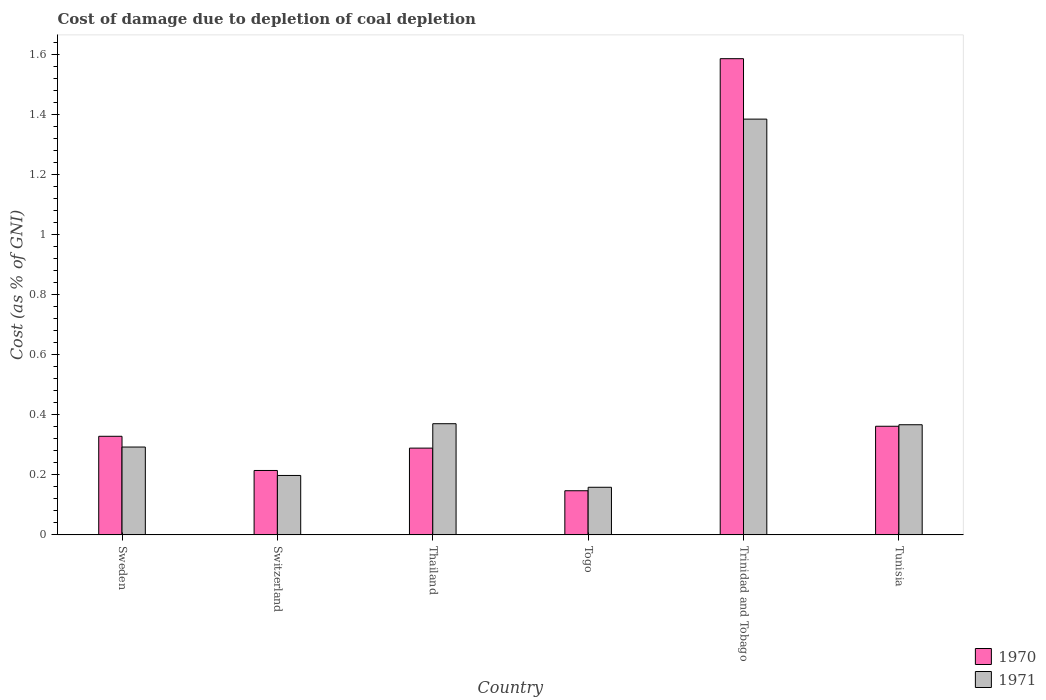How many groups of bars are there?
Offer a terse response. 6. Are the number of bars on each tick of the X-axis equal?
Keep it short and to the point. Yes. How many bars are there on the 6th tick from the left?
Provide a short and direct response. 2. What is the label of the 3rd group of bars from the left?
Your answer should be compact. Thailand. What is the cost of damage caused due to coal depletion in 1971 in Switzerland?
Offer a terse response. 0.2. Across all countries, what is the maximum cost of damage caused due to coal depletion in 1971?
Ensure brevity in your answer.  1.39. Across all countries, what is the minimum cost of damage caused due to coal depletion in 1971?
Provide a succinct answer. 0.16. In which country was the cost of damage caused due to coal depletion in 1970 maximum?
Provide a succinct answer. Trinidad and Tobago. In which country was the cost of damage caused due to coal depletion in 1970 minimum?
Your answer should be very brief. Togo. What is the total cost of damage caused due to coal depletion in 1970 in the graph?
Your answer should be very brief. 2.93. What is the difference between the cost of damage caused due to coal depletion in 1971 in Trinidad and Tobago and that in Tunisia?
Keep it short and to the point. 1.02. What is the difference between the cost of damage caused due to coal depletion in 1971 in Switzerland and the cost of damage caused due to coal depletion in 1970 in Trinidad and Tobago?
Your response must be concise. -1.39. What is the average cost of damage caused due to coal depletion in 1971 per country?
Offer a very short reply. 0.46. What is the difference between the cost of damage caused due to coal depletion of/in 1971 and cost of damage caused due to coal depletion of/in 1970 in Switzerland?
Provide a short and direct response. -0.02. What is the ratio of the cost of damage caused due to coal depletion in 1970 in Sweden to that in Tunisia?
Keep it short and to the point. 0.91. Is the cost of damage caused due to coal depletion in 1971 in Togo less than that in Trinidad and Tobago?
Your answer should be compact. Yes. What is the difference between the highest and the second highest cost of damage caused due to coal depletion in 1970?
Give a very brief answer. -1.23. What is the difference between the highest and the lowest cost of damage caused due to coal depletion in 1970?
Your answer should be very brief. 1.44. In how many countries, is the cost of damage caused due to coal depletion in 1971 greater than the average cost of damage caused due to coal depletion in 1971 taken over all countries?
Your answer should be compact. 1. How many bars are there?
Your answer should be compact. 12. Are all the bars in the graph horizontal?
Ensure brevity in your answer.  No. How many countries are there in the graph?
Your answer should be compact. 6. What is the difference between two consecutive major ticks on the Y-axis?
Offer a terse response. 0.2. Are the values on the major ticks of Y-axis written in scientific E-notation?
Offer a very short reply. No. Does the graph contain any zero values?
Offer a terse response. No. How are the legend labels stacked?
Offer a very short reply. Vertical. What is the title of the graph?
Ensure brevity in your answer.  Cost of damage due to depletion of coal depletion. Does "1987" appear as one of the legend labels in the graph?
Make the answer very short. No. What is the label or title of the X-axis?
Offer a very short reply. Country. What is the label or title of the Y-axis?
Offer a terse response. Cost (as % of GNI). What is the Cost (as % of GNI) in 1970 in Sweden?
Your response must be concise. 0.33. What is the Cost (as % of GNI) in 1971 in Sweden?
Provide a succinct answer. 0.29. What is the Cost (as % of GNI) in 1970 in Switzerland?
Provide a succinct answer. 0.21. What is the Cost (as % of GNI) in 1971 in Switzerland?
Give a very brief answer. 0.2. What is the Cost (as % of GNI) of 1970 in Thailand?
Provide a short and direct response. 0.29. What is the Cost (as % of GNI) of 1971 in Thailand?
Make the answer very short. 0.37. What is the Cost (as % of GNI) of 1970 in Togo?
Your answer should be very brief. 0.15. What is the Cost (as % of GNI) of 1971 in Togo?
Your response must be concise. 0.16. What is the Cost (as % of GNI) in 1970 in Trinidad and Tobago?
Offer a very short reply. 1.59. What is the Cost (as % of GNI) of 1971 in Trinidad and Tobago?
Keep it short and to the point. 1.39. What is the Cost (as % of GNI) in 1970 in Tunisia?
Your answer should be compact. 0.36. What is the Cost (as % of GNI) in 1971 in Tunisia?
Offer a terse response. 0.37. Across all countries, what is the maximum Cost (as % of GNI) in 1970?
Keep it short and to the point. 1.59. Across all countries, what is the maximum Cost (as % of GNI) in 1971?
Make the answer very short. 1.39. Across all countries, what is the minimum Cost (as % of GNI) of 1970?
Your response must be concise. 0.15. Across all countries, what is the minimum Cost (as % of GNI) of 1971?
Keep it short and to the point. 0.16. What is the total Cost (as % of GNI) of 1970 in the graph?
Your answer should be compact. 2.93. What is the total Cost (as % of GNI) in 1971 in the graph?
Offer a terse response. 2.77. What is the difference between the Cost (as % of GNI) of 1970 in Sweden and that in Switzerland?
Your answer should be compact. 0.11. What is the difference between the Cost (as % of GNI) of 1971 in Sweden and that in Switzerland?
Your answer should be compact. 0.09. What is the difference between the Cost (as % of GNI) of 1970 in Sweden and that in Thailand?
Offer a very short reply. 0.04. What is the difference between the Cost (as % of GNI) in 1971 in Sweden and that in Thailand?
Your answer should be very brief. -0.08. What is the difference between the Cost (as % of GNI) in 1970 in Sweden and that in Togo?
Offer a very short reply. 0.18. What is the difference between the Cost (as % of GNI) of 1971 in Sweden and that in Togo?
Provide a succinct answer. 0.13. What is the difference between the Cost (as % of GNI) in 1970 in Sweden and that in Trinidad and Tobago?
Ensure brevity in your answer.  -1.26. What is the difference between the Cost (as % of GNI) of 1971 in Sweden and that in Trinidad and Tobago?
Offer a terse response. -1.09. What is the difference between the Cost (as % of GNI) of 1970 in Sweden and that in Tunisia?
Your answer should be very brief. -0.03. What is the difference between the Cost (as % of GNI) in 1971 in Sweden and that in Tunisia?
Provide a succinct answer. -0.07. What is the difference between the Cost (as % of GNI) in 1970 in Switzerland and that in Thailand?
Provide a short and direct response. -0.07. What is the difference between the Cost (as % of GNI) in 1971 in Switzerland and that in Thailand?
Make the answer very short. -0.17. What is the difference between the Cost (as % of GNI) of 1970 in Switzerland and that in Togo?
Your response must be concise. 0.07. What is the difference between the Cost (as % of GNI) of 1971 in Switzerland and that in Togo?
Your answer should be very brief. 0.04. What is the difference between the Cost (as % of GNI) in 1970 in Switzerland and that in Trinidad and Tobago?
Provide a succinct answer. -1.37. What is the difference between the Cost (as % of GNI) in 1971 in Switzerland and that in Trinidad and Tobago?
Offer a terse response. -1.19. What is the difference between the Cost (as % of GNI) of 1970 in Switzerland and that in Tunisia?
Offer a terse response. -0.15. What is the difference between the Cost (as % of GNI) of 1971 in Switzerland and that in Tunisia?
Keep it short and to the point. -0.17. What is the difference between the Cost (as % of GNI) of 1970 in Thailand and that in Togo?
Your answer should be compact. 0.14. What is the difference between the Cost (as % of GNI) of 1971 in Thailand and that in Togo?
Your response must be concise. 0.21. What is the difference between the Cost (as % of GNI) of 1970 in Thailand and that in Trinidad and Tobago?
Offer a very short reply. -1.3. What is the difference between the Cost (as % of GNI) in 1971 in Thailand and that in Trinidad and Tobago?
Your answer should be very brief. -1.02. What is the difference between the Cost (as % of GNI) in 1970 in Thailand and that in Tunisia?
Make the answer very short. -0.07. What is the difference between the Cost (as % of GNI) in 1971 in Thailand and that in Tunisia?
Provide a succinct answer. 0. What is the difference between the Cost (as % of GNI) of 1970 in Togo and that in Trinidad and Tobago?
Make the answer very short. -1.44. What is the difference between the Cost (as % of GNI) in 1971 in Togo and that in Trinidad and Tobago?
Your answer should be very brief. -1.23. What is the difference between the Cost (as % of GNI) of 1970 in Togo and that in Tunisia?
Offer a terse response. -0.21. What is the difference between the Cost (as % of GNI) of 1971 in Togo and that in Tunisia?
Give a very brief answer. -0.21. What is the difference between the Cost (as % of GNI) of 1970 in Trinidad and Tobago and that in Tunisia?
Provide a short and direct response. 1.23. What is the difference between the Cost (as % of GNI) of 1971 in Trinidad and Tobago and that in Tunisia?
Give a very brief answer. 1.02. What is the difference between the Cost (as % of GNI) in 1970 in Sweden and the Cost (as % of GNI) in 1971 in Switzerland?
Your answer should be very brief. 0.13. What is the difference between the Cost (as % of GNI) of 1970 in Sweden and the Cost (as % of GNI) of 1971 in Thailand?
Offer a terse response. -0.04. What is the difference between the Cost (as % of GNI) in 1970 in Sweden and the Cost (as % of GNI) in 1971 in Togo?
Offer a very short reply. 0.17. What is the difference between the Cost (as % of GNI) in 1970 in Sweden and the Cost (as % of GNI) in 1971 in Trinidad and Tobago?
Ensure brevity in your answer.  -1.06. What is the difference between the Cost (as % of GNI) in 1970 in Sweden and the Cost (as % of GNI) in 1971 in Tunisia?
Provide a succinct answer. -0.04. What is the difference between the Cost (as % of GNI) of 1970 in Switzerland and the Cost (as % of GNI) of 1971 in Thailand?
Provide a succinct answer. -0.16. What is the difference between the Cost (as % of GNI) in 1970 in Switzerland and the Cost (as % of GNI) in 1971 in Togo?
Offer a terse response. 0.06. What is the difference between the Cost (as % of GNI) of 1970 in Switzerland and the Cost (as % of GNI) of 1971 in Trinidad and Tobago?
Offer a terse response. -1.17. What is the difference between the Cost (as % of GNI) of 1970 in Switzerland and the Cost (as % of GNI) of 1971 in Tunisia?
Provide a short and direct response. -0.15. What is the difference between the Cost (as % of GNI) in 1970 in Thailand and the Cost (as % of GNI) in 1971 in Togo?
Keep it short and to the point. 0.13. What is the difference between the Cost (as % of GNI) in 1970 in Thailand and the Cost (as % of GNI) in 1971 in Trinidad and Tobago?
Ensure brevity in your answer.  -1.1. What is the difference between the Cost (as % of GNI) of 1970 in Thailand and the Cost (as % of GNI) of 1971 in Tunisia?
Offer a terse response. -0.08. What is the difference between the Cost (as % of GNI) of 1970 in Togo and the Cost (as % of GNI) of 1971 in Trinidad and Tobago?
Give a very brief answer. -1.24. What is the difference between the Cost (as % of GNI) in 1970 in Togo and the Cost (as % of GNI) in 1971 in Tunisia?
Offer a very short reply. -0.22. What is the difference between the Cost (as % of GNI) in 1970 in Trinidad and Tobago and the Cost (as % of GNI) in 1971 in Tunisia?
Offer a very short reply. 1.22. What is the average Cost (as % of GNI) of 1970 per country?
Offer a very short reply. 0.49. What is the average Cost (as % of GNI) of 1971 per country?
Provide a succinct answer. 0.46. What is the difference between the Cost (as % of GNI) in 1970 and Cost (as % of GNI) in 1971 in Sweden?
Keep it short and to the point. 0.04. What is the difference between the Cost (as % of GNI) in 1970 and Cost (as % of GNI) in 1971 in Switzerland?
Your answer should be compact. 0.02. What is the difference between the Cost (as % of GNI) of 1970 and Cost (as % of GNI) of 1971 in Thailand?
Your answer should be very brief. -0.08. What is the difference between the Cost (as % of GNI) of 1970 and Cost (as % of GNI) of 1971 in Togo?
Ensure brevity in your answer.  -0.01. What is the difference between the Cost (as % of GNI) of 1970 and Cost (as % of GNI) of 1971 in Trinidad and Tobago?
Ensure brevity in your answer.  0.2. What is the difference between the Cost (as % of GNI) in 1970 and Cost (as % of GNI) in 1971 in Tunisia?
Give a very brief answer. -0.01. What is the ratio of the Cost (as % of GNI) of 1970 in Sweden to that in Switzerland?
Offer a terse response. 1.53. What is the ratio of the Cost (as % of GNI) in 1971 in Sweden to that in Switzerland?
Your response must be concise. 1.48. What is the ratio of the Cost (as % of GNI) in 1970 in Sweden to that in Thailand?
Your response must be concise. 1.14. What is the ratio of the Cost (as % of GNI) in 1971 in Sweden to that in Thailand?
Provide a short and direct response. 0.79. What is the ratio of the Cost (as % of GNI) in 1970 in Sweden to that in Togo?
Provide a short and direct response. 2.23. What is the ratio of the Cost (as % of GNI) of 1971 in Sweden to that in Togo?
Provide a short and direct response. 1.84. What is the ratio of the Cost (as % of GNI) of 1970 in Sweden to that in Trinidad and Tobago?
Make the answer very short. 0.21. What is the ratio of the Cost (as % of GNI) in 1971 in Sweden to that in Trinidad and Tobago?
Provide a short and direct response. 0.21. What is the ratio of the Cost (as % of GNI) in 1970 in Sweden to that in Tunisia?
Offer a very short reply. 0.91. What is the ratio of the Cost (as % of GNI) of 1971 in Sweden to that in Tunisia?
Your response must be concise. 0.8. What is the ratio of the Cost (as % of GNI) in 1970 in Switzerland to that in Thailand?
Keep it short and to the point. 0.74. What is the ratio of the Cost (as % of GNI) of 1971 in Switzerland to that in Thailand?
Provide a short and direct response. 0.53. What is the ratio of the Cost (as % of GNI) of 1970 in Switzerland to that in Togo?
Ensure brevity in your answer.  1.46. What is the ratio of the Cost (as % of GNI) in 1971 in Switzerland to that in Togo?
Provide a succinct answer. 1.25. What is the ratio of the Cost (as % of GNI) in 1970 in Switzerland to that in Trinidad and Tobago?
Offer a very short reply. 0.14. What is the ratio of the Cost (as % of GNI) of 1971 in Switzerland to that in Trinidad and Tobago?
Ensure brevity in your answer.  0.14. What is the ratio of the Cost (as % of GNI) in 1970 in Switzerland to that in Tunisia?
Make the answer very short. 0.59. What is the ratio of the Cost (as % of GNI) of 1971 in Switzerland to that in Tunisia?
Keep it short and to the point. 0.54. What is the ratio of the Cost (as % of GNI) in 1970 in Thailand to that in Togo?
Your answer should be compact. 1.97. What is the ratio of the Cost (as % of GNI) of 1971 in Thailand to that in Togo?
Offer a very short reply. 2.33. What is the ratio of the Cost (as % of GNI) of 1970 in Thailand to that in Trinidad and Tobago?
Your response must be concise. 0.18. What is the ratio of the Cost (as % of GNI) of 1971 in Thailand to that in Trinidad and Tobago?
Offer a very short reply. 0.27. What is the ratio of the Cost (as % of GNI) of 1970 in Thailand to that in Tunisia?
Your answer should be very brief. 0.8. What is the ratio of the Cost (as % of GNI) in 1971 in Thailand to that in Tunisia?
Provide a succinct answer. 1.01. What is the ratio of the Cost (as % of GNI) of 1970 in Togo to that in Trinidad and Tobago?
Provide a succinct answer. 0.09. What is the ratio of the Cost (as % of GNI) in 1971 in Togo to that in Trinidad and Tobago?
Offer a terse response. 0.11. What is the ratio of the Cost (as % of GNI) in 1970 in Togo to that in Tunisia?
Provide a short and direct response. 0.41. What is the ratio of the Cost (as % of GNI) in 1971 in Togo to that in Tunisia?
Give a very brief answer. 0.43. What is the ratio of the Cost (as % of GNI) in 1970 in Trinidad and Tobago to that in Tunisia?
Provide a succinct answer. 4.38. What is the ratio of the Cost (as % of GNI) of 1971 in Trinidad and Tobago to that in Tunisia?
Provide a short and direct response. 3.77. What is the difference between the highest and the second highest Cost (as % of GNI) of 1970?
Provide a short and direct response. 1.23. What is the difference between the highest and the second highest Cost (as % of GNI) of 1971?
Your response must be concise. 1.02. What is the difference between the highest and the lowest Cost (as % of GNI) of 1970?
Ensure brevity in your answer.  1.44. What is the difference between the highest and the lowest Cost (as % of GNI) in 1971?
Your answer should be very brief. 1.23. 